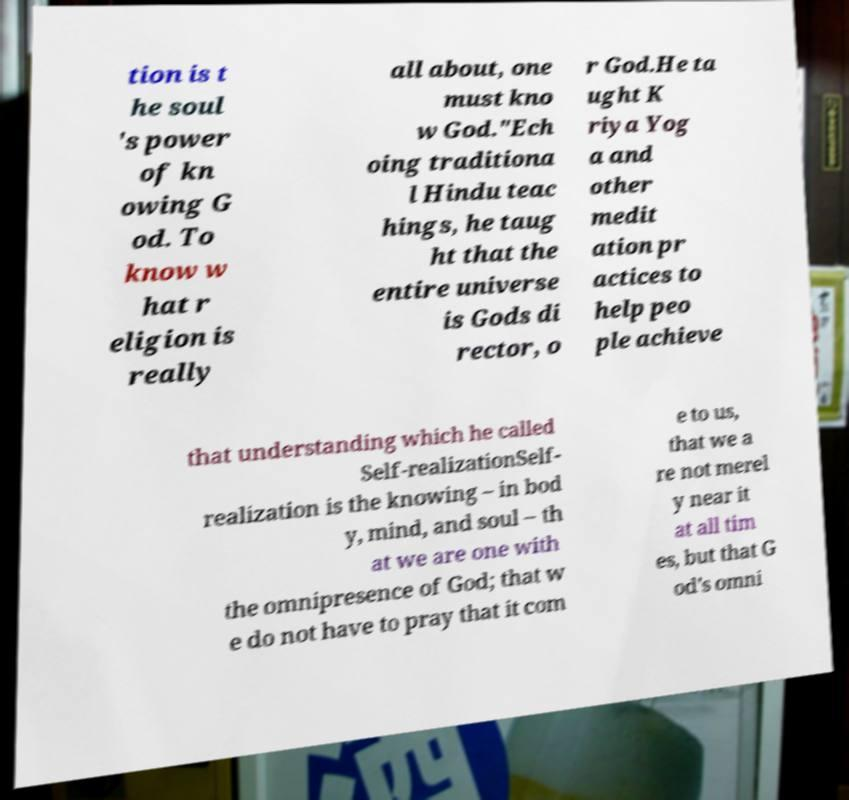For documentation purposes, I need the text within this image transcribed. Could you provide that? tion is t he soul 's power of kn owing G od. To know w hat r eligion is really all about, one must kno w God."Ech oing traditiona l Hindu teac hings, he taug ht that the entire universe is Gods di rector, o r God.He ta ught K riya Yog a and other medit ation pr actices to help peo ple achieve that understanding which he called Self-realizationSelf- realization is the knowing – in bod y, mind, and soul – th at we are one with the omnipresence of God; that w e do not have to pray that it com e to us, that we a re not merel y near it at all tim es, but that G od's omni 